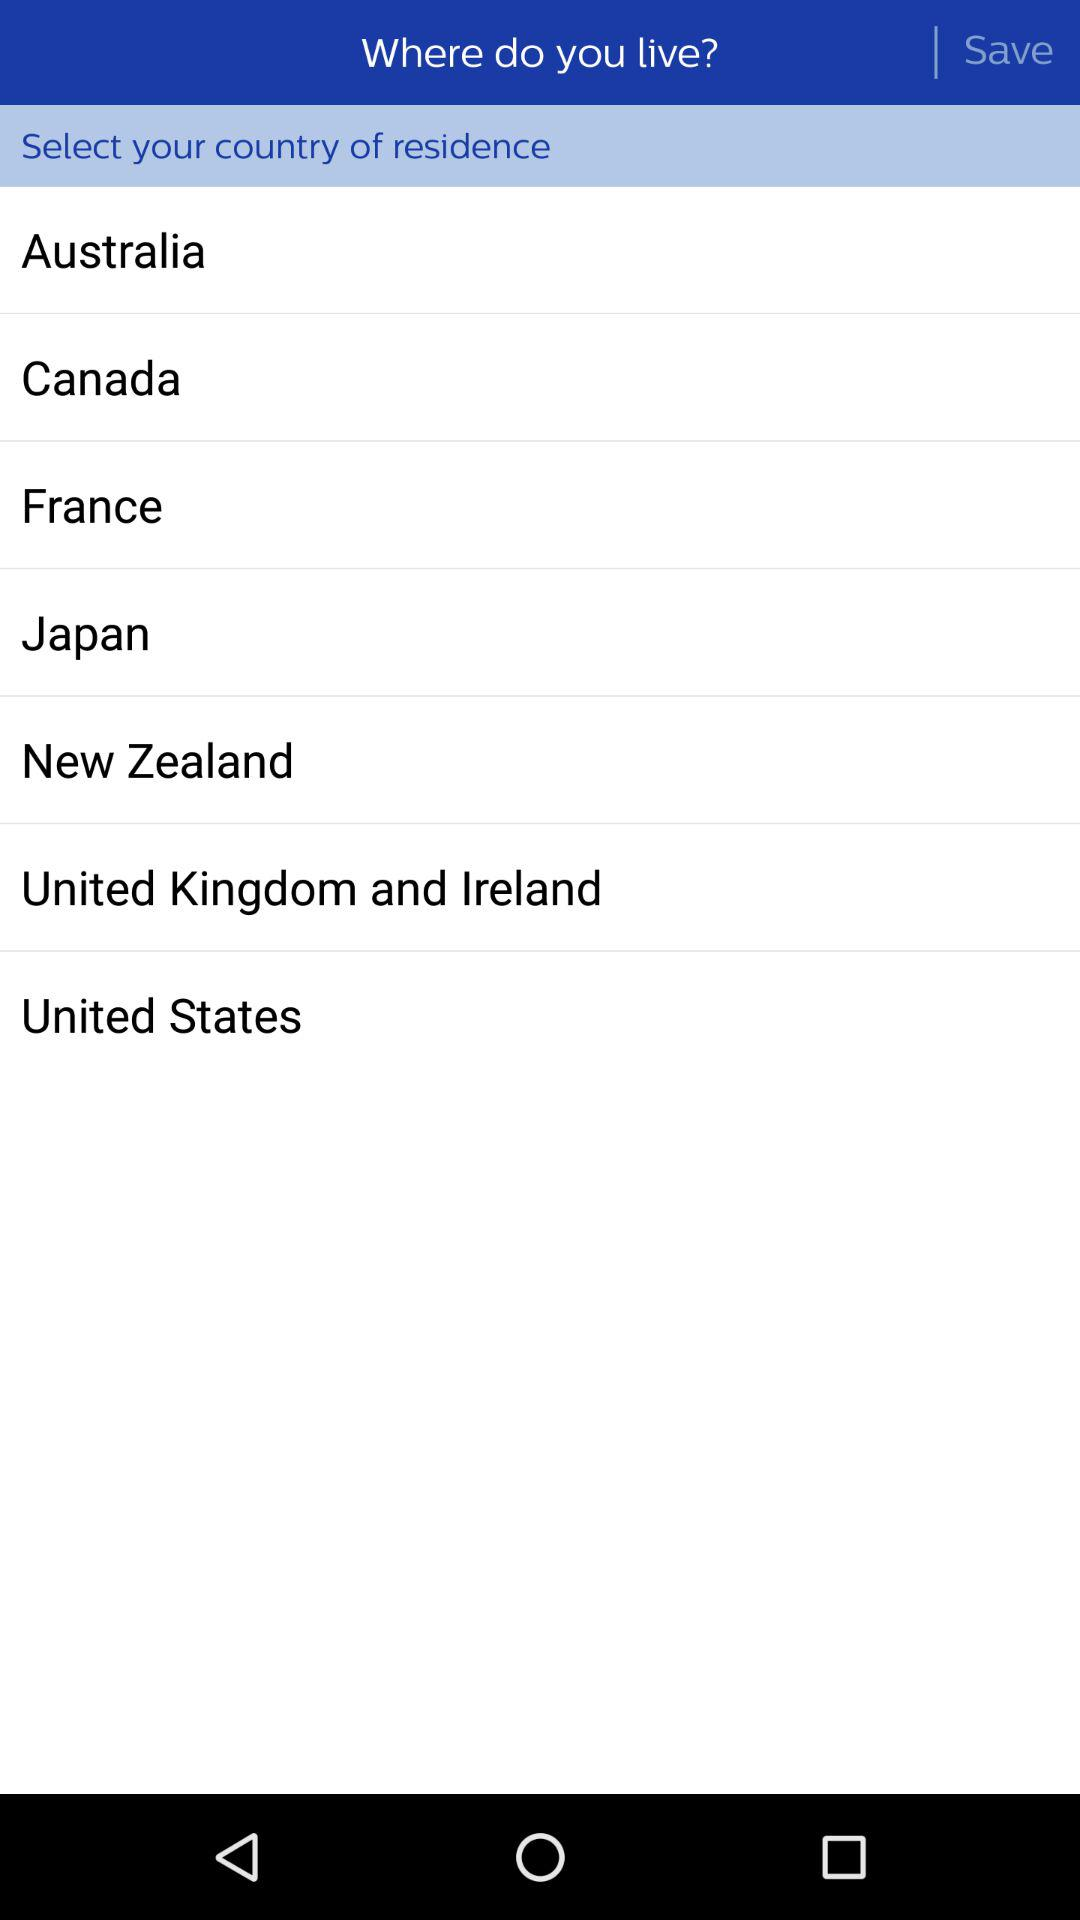What country options are there that I can select as my country of residence? The options are "Australia", "Canada", "France", "Japan", "New Zealand", "United Kingdom and Ireland" and "United States". 